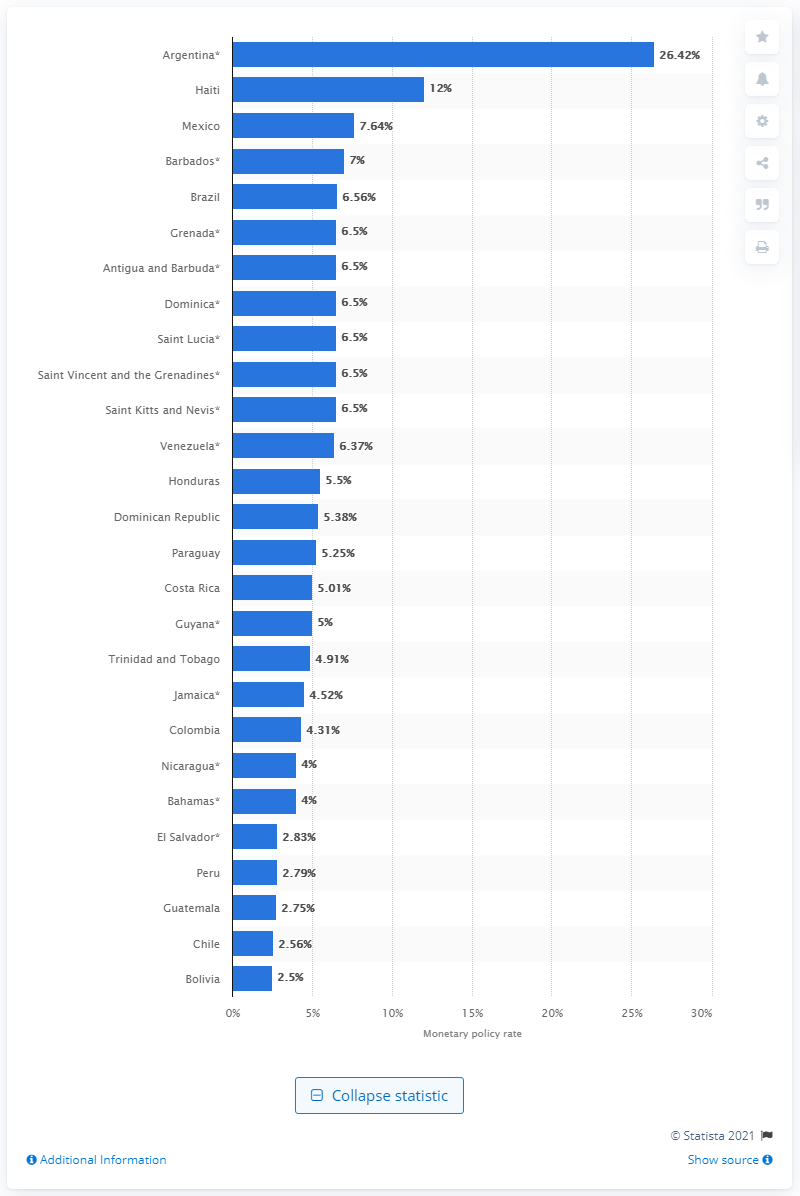List a handful of essential elements in this visual. In 2017, the monetary policy rate in Argentina was 26.42%. The base interest rate in Mexico in 2018 was 7.64%. 